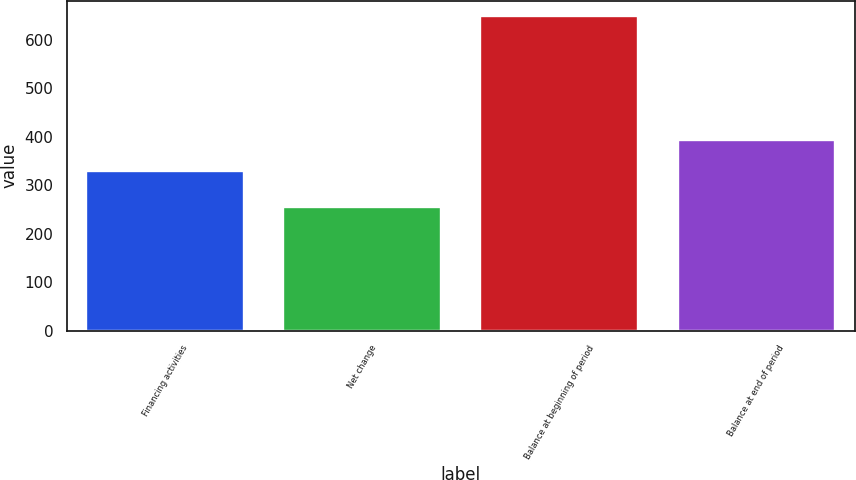<chart> <loc_0><loc_0><loc_500><loc_500><bar_chart><fcel>Financing activities<fcel>Net change<fcel>Balance at beginning of period<fcel>Balance at end of period<nl><fcel>330<fcel>254<fcel>648<fcel>394<nl></chart> 